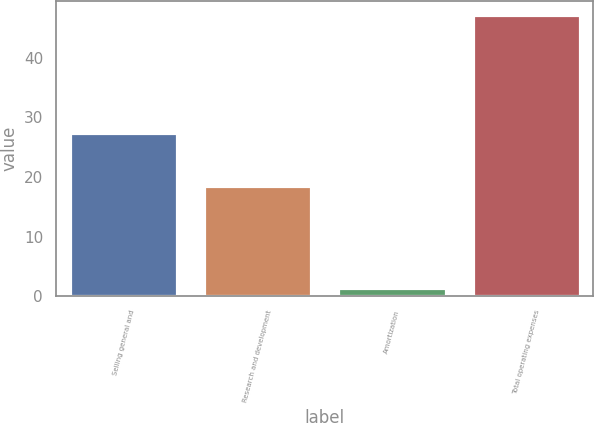Convert chart to OTSL. <chart><loc_0><loc_0><loc_500><loc_500><bar_chart><fcel>Selling general and<fcel>Research and development<fcel>Amortization<fcel>Total operating expenses<nl><fcel>27.3<fcel>18.5<fcel>1.3<fcel>47.1<nl></chart> 